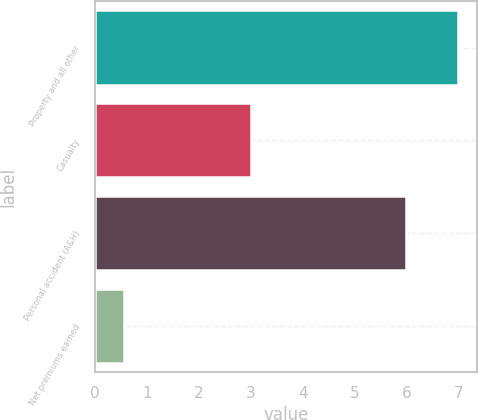Convert chart to OTSL. <chart><loc_0><loc_0><loc_500><loc_500><bar_chart><fcel>Property and all other<fcel>Casualty<fcel>Personal accident (A&H)<fcel>Net premiums earned<nl><fcel>7<fcel>3<fcel>6<fcel>0.56<nl></chart> 